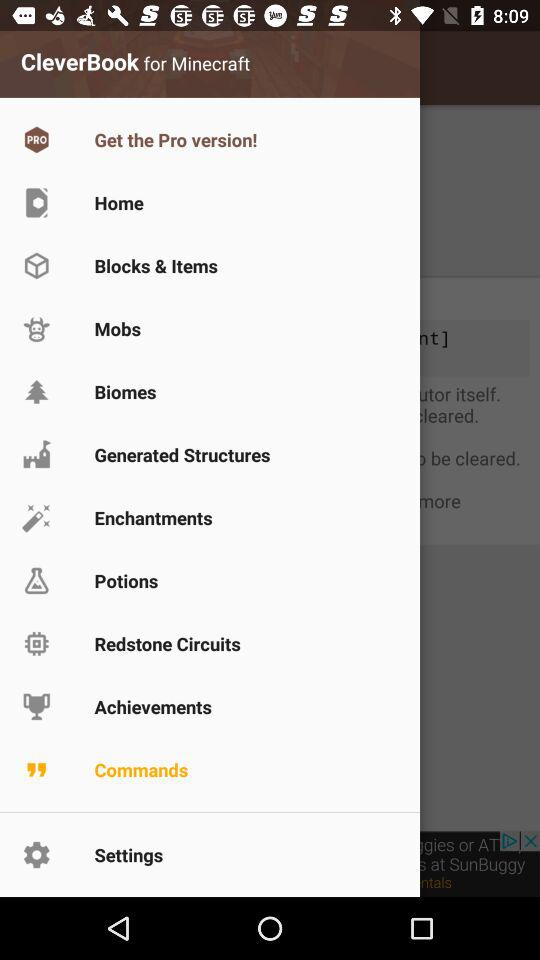What is the application name? The application name is "CleverBook for Minecraft". 